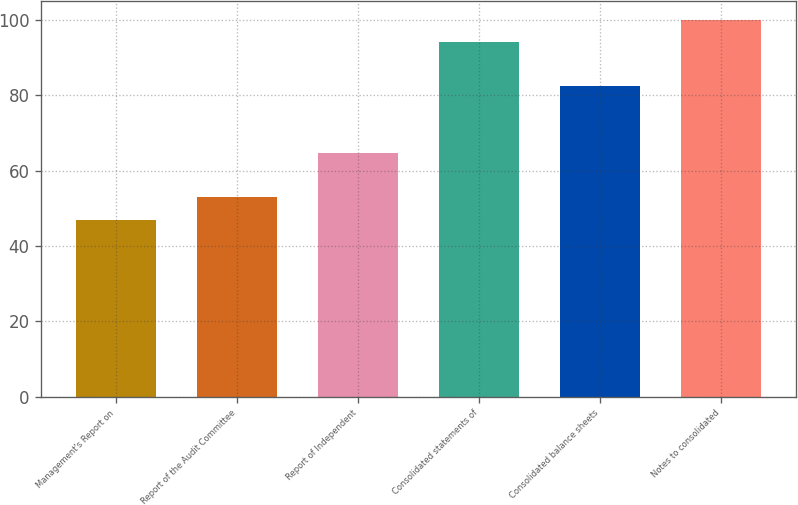Convert chart. <chart><loc_0><loc_0><loc_500><loc_500><bar_chart><fcel>Management's Report on<fcel>Report of the Audit Committee<fcel>Report of Independent<fcel>Consolidated statements of<fcel>Consolidated balance sheets<fcel>Notes to consolidated<nl><fcel>47<fcel>52.9<fcel>64.7<fcel>94.2<fcel>82.4<fcel>100.1<nl></chart> 